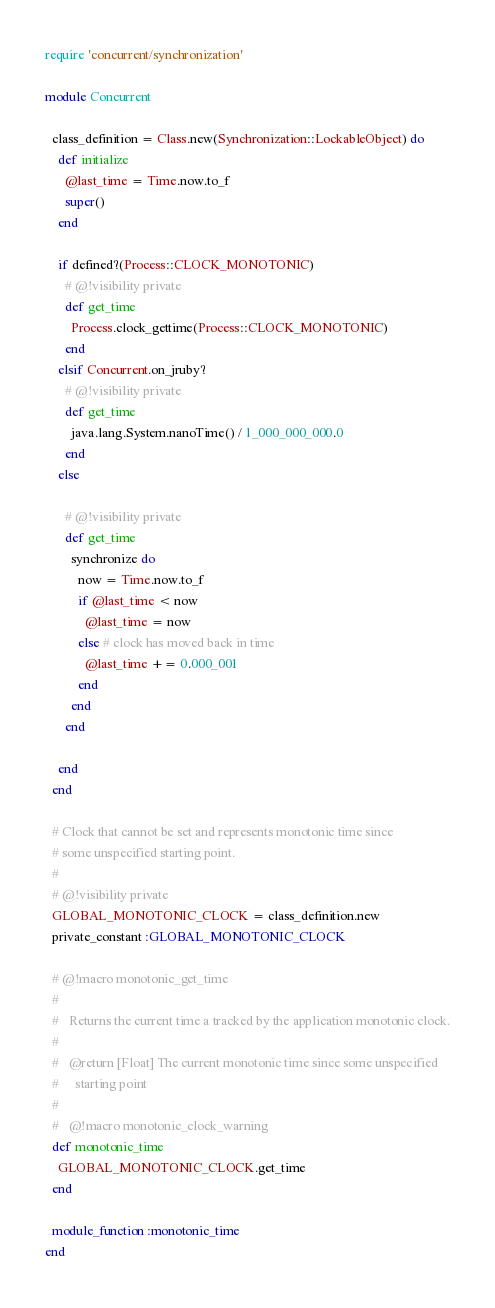Convert code to text. <code><loc_0><loc_0><loc_500><loc_500><_Ruby_>require 'concurrent/synchronization'

module Concurrent

  class_definition = Class.new(Synchronization::LockableObject) do
    def initialize
      @last_time = Time.now.to_f
      super()
    end

    if defined?(Process::CLOCK_MONOTONIC)
      # @!visibility private
      def get_time
        Process.clock_gettime(Process::CLOCK_MONOTONIC)
      end
    elsif Concurrent.on_jruby?
      # @!visibility private
      def get_time
        java.lang.System.nanoTime() / 1_000_000_000.0
      end
    else

      # @!visibility private
      def get_time
        synchronize do
          now = Time.now.to_f
          if @last_time < now
            @last_time = now
          else # clock has moved back in time
            @last_time += 0.000_001
          end
        end
      end

    end
  end

  # Clock that cannot be set and represents monotonic time since
  # some unspecified starting point.
  #
  # @!visibility private
  GLOBAL_MONOTONIC_CLOCK = class_definition.new
  private_constant :GLOBAL_MONOTONIC_CLOCK

  # @!macro monotonic_get_time
  #
  #   Returns the current time a tracked by the application monotonic clock.
  #
  #   @return [Float] The current monotonic time since some unspecified
  #     starting point
  #
  #   @!macro monotonic_clock_warning
  def monotonic_time
    GLOBAL_MONOTONIC_CLOCK.get_time
  end

  module_function :monotonic_time
end
</code> 